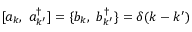Convert formula to latex. <formula><loc_0><loc_0><loc_500><loc_500>[ a _ { k } , a _ { k ^ { \prime } } ^ { \dagger } ] = \{ b _ { k } , b _ { k ^ { \prime } } ^ { \dagger } \} = \delta ( k - k ^ { \prime } )</formula> 